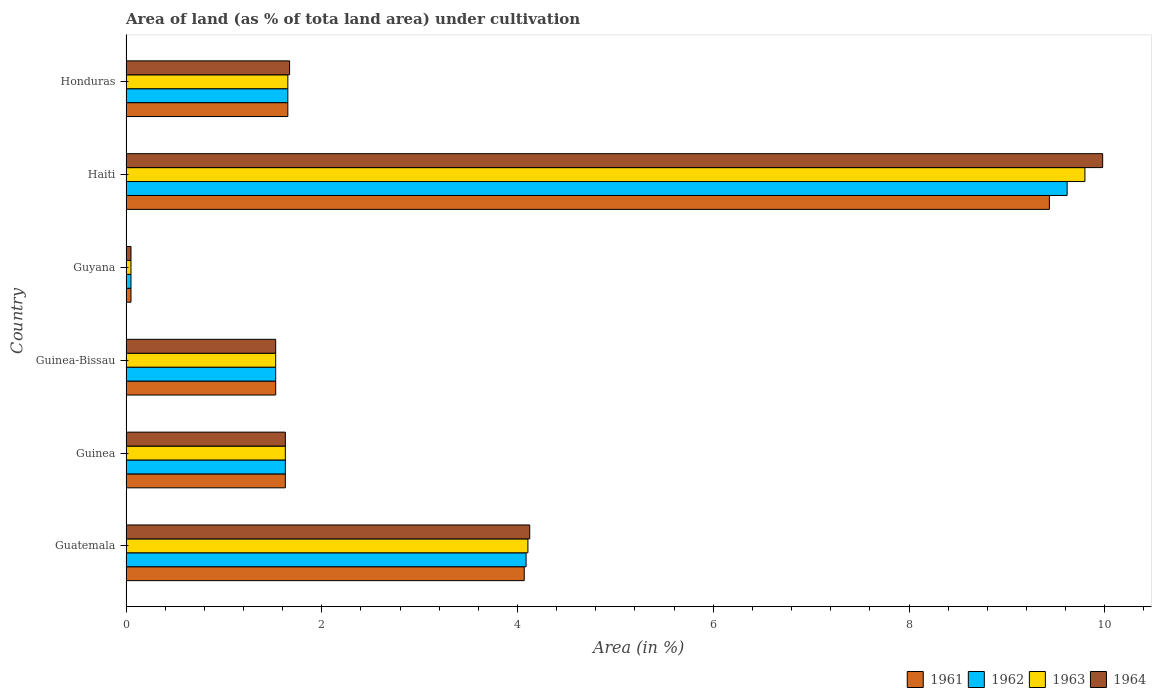Are the number of bars per tick equal to the number of legend labels?
Give a very brief answer. Yes. What is the label of the 1st group of bars from the top?
Make the answer very short. Honduras. What is the percentage of land under cultivation in 1963 in Honduras?
Provide a succinct answer. 1.65. Across all countries, what is the maximum percentage of land under cultivation in 1962?
Your response must be concise. 9.62. Across all countries, what is the minimum percentage of land under cultivation in 1964?
Give a very brief answer. 0.05. In which country was the percentage of land under cultivation in 1963 maximum?
Give a very brief answer. Haiti. In which country was the percentage of land under cultivation in 1964 minimum?
Your answer should be compact. Guyana. What is the total percentage of land under cultivation in 1964 in the graph?
Ensure brevity in your answer.  18.98. What is the difference between the percentage of land under cultivation in 1963 in Guinea and that in Honduras?
Provide a succinct answer. -0.03. What is the difference between the percentage of land under cultivation in 1962 in Guatemala and the percentage of land under cultivation in 1963 in Haiti?
Offer a very short reply. -5.71. What is the average percentage of land under cultivation in 1962 per country?
Give a very brief answer. 3.09. What is the difference between the percentage of land under cultivation in 1961 and percentage of land under cultivation in 1962 in Guatemala?
Your answer should be compact. -0.02. In how many countries, is the percentage of land under cultivation in 1962 greater than 0.8 %?
Ensure brevity in your answer.  5. What is the ratio of the percentage of land under cultivation in 1962 in Guatemala to that in Honduras?
Provide a short and direct response. 2.47. Is the percentage of land under cultivation in 1962 in Guinea less than that in Honduras?
Provide a succinct answer. Yes. Is the difference between the percentage of land under cultivation in 1961 in Guinea and Guyana greater than the difference between the percentage of land under cultivation in 1962 in Guinea and Guyana?
Offer a terse response. No. What is the difference between the highest and the second highest percentage of land under cultivation in 1961?
Your answer should be very brief. 5.37. What is the difference between the highest and the lowest percentage of land under cultivation in 1962?
Your response must be concise. 9.56. Is the sum of the percentage of land under cultivation in 1963 in Guinea-Bissau and Honduras greater than the maximum percentage of land under cultivation in 1961 across all countries?
Ensure brevity in your answer.  No. What does the 3rd bar from the bottom in Honduras represents?
Ensure brevity in your answer.  1963. How many bars are there?
Offer a terse response. 24. How many countries are there in the graph?
Ensure brevity in your answer.  6. Does the graph contain any zero values?
Provide a succinct answer. No. What is the title of the graph?
Offer a terse response. Area of land (as % of tota land area) under cultivation. What is the label or title of the X-axis?
Provide a succinct answer. Area (in %). What is the label or title of the Y-axis?
Make the answer very short. Country. What is the Area (in %) of 1961 in Guatemala?
Give a very brief answer. 4.07. What is the Area (in %) in 1962 in Guatemala?
Your response must be concise. 4.09. What is the Area (in %) in 1963 in Guatemala?
Ensure brevity in your answer.  4.11. What is the Area (in %) in 1964 in Guatemala?
Keep it short and to the point. 4.12. What is the Area (in %) of 1961 in Guinea?
Ensure brevity in your answer.  1.63. What is the Area (in %) in 1962 in Guinea?
Offer a terse response. 1.63. What is the Area (in %) of 1963 in Guinea?
Your response must be concise. 1.63. What is the Area (in %) of 1964 in Guinea?
Provide a succinct answer. 1.63. What is the Area (in %) in 1961 in Guinea-Bissau?
Offer a very short reply. 1.53. What is the Area (in %) in 1962 in Guinea-Bissau?
Your answer should be compact. 1.53. What is the Area (in %) of 1963 in Guinea-Bissau?
Provide a short and direct response. 1.53. What is the Area (in %) in 1964 in Guinea-Bissau?
Your answer should be very brief. 1.53. What is the Area (in %) in 1961 in Guyana?
Keep it short and to the point. 0.05. What is the Area (in %) in 1962 in Guyana?
Your answer should be very brief. 0.05. What is the Area (in %) of 1963 in Guyana?
Offer a very short reply. 0.05. What is the Area (in %) of 1964 in Guyana?
Your answer should be very brief. 0.05. What is the Area (in %) in 1961 in Haiti?
Give a very brief answer. 9.43. What is the Area (in %) of 1962 in Haiti?
Give a very brief answer. 9.62. What is the Area (in %) in 1963 in Haiti?
Make the answer very short. 9.8. What is the Area (in %) of 1964 in Haiti?
Offer a terse response. 9.98. What is the Area (in %) in 1961 in Honduras?
Your answer should be compact. 1.65. What is the Area (in %) in 1962 in Honduras?
Offer a very short reply. 1.65. What is the Area (in %) in 1963 in Honduras?
Ensure brevity in your answer.  1.65. What is the Area (in %) of 1964 in Honduras?
Ensure brevity in your answer.  1.67. Across all countries, what is the maximum Area (in %) of 1961?
Your response must be concise. 9.43. Across all countries, what is the maximum Area (in %) in 1962?
Make the answer very short. 9.62. Across all countries, what is the maximum Area (in %) in 1963?
Your answer should be compact. 9.8. Across all countries, what is the maximum Area (in %) of 1964?
Give a very brief answer. 9.98. Across all countries, what is the minimum Area (in %) in 1961?
Offer a very short reply. 0.05. Across all countries, what is the minimum Area (in %) of 1962?
Provide a short and direct response. 0.05. Across all countries, what is the minimum Area (in %) in 1963?
Offer a very short reply. 0.05. Across all countries, what is the minimum Area (in %) in 1964?
Give a very brief answer. 0.05. What is the total Area (in %) in 1961 in the graph?
Keep it short and to the point. 18.36. What is the total Area (in %) in 1962 in the graph?
Your response must be concise. 18.56. What is the total Area (in %) of 1963 in the graph?
Provide a short and direct response. 18.76. What is the total Area (in %) of 1964 in the graph?
Provide a short and direct response. 18.98. What is the difference between the Area (in %) of 1961 in Guatemala and that in Guinea?
Provide a short and direct response. 2.44. What is the difference between the Area (in %) in 1962 in Guatemala and that in Guinea?
Offer a terse response. 2.46. What is the difference between the Area (in %) in 1963 in Guatemala and that in Guinea?
Your answer should be very brief. 2.48. What is the difference between the Area (in %) of 1964 in Guatemala and that in Guinea?
Your response must be concise. 2.5. What is the difference between the Area (in %) in 1961 in Guatemala and that in Guinea-Bissau?
Your answer should be compact. 2.54. What is the difference between the Area (in %) of 1962 in Guatemala and that in Guinea-Bissau?
Provide a short and direct response. 2.56. What is the difference between the Area (in %) of 1963 in Guatemala and that in Guinea-Bissau?
Offer a very short reply. 2.58. What is the difference between the Area (in %) of 1964 in Guatemala and that in Guinea-Bissau?
Keep it short and to the point. 2.6. What is the difference between the Area (in %) in 1961 in Guatemala and that in Guyana?
Your answer should be very brief. 4.02. What is the difference between the Area (in %) of 1962 in Guatemala and that in Guyana?
Your answer should be very brief. 4.04. What is the difference between the Area (in %) of 1963 in Guatemala and that in Guyana?
Give a very brief answer. 4.06. What is the difference between the Area (in %) of 1964 in Guatemala and that in Guyana?
Keep it short and to the point. 4.07. What is the difference between the Area (in %) of 1961 in Guatemala and that in Haiti?
Provide a succinct answer. -5.37. What is the difference between the Area (in %) in 1962 in Guatemala and that in Haiti?
Ensure brevity in your answer.  -5.53. What is the difference between the Area (in %) in 1963 in Guatemala and that in Haiti?
Keep it short and to the point. -5.69. What is the difference between the Area (in %) in 1964 in Guatemala and that in Haiti?
Keep it short and to the point. -5.85. What is the difference between the Area (in %) of 1961 in Guatemala and that in Honduras?
Keep it short and to the point. 2.42. What is the difference between the Area (in %) of 1962 in Guatemala and that in Honduras?
Provide a succinct answer. 2.43. What is the difference between the Area (in %) in 1963 in Guatemala and that in Honduras?
Give a very brief answer. 2.45. What is the difference between the Area (in %) of 1964 in Guatemala and that in Honduras?
Offer a terse response. 2.45. What is the difference between the Area (in %) of 1961 in Guinea and that in Guinea-Bissau?
Make the answer very short. 0.1. What is the difference between the Area (in %) of 1962 in Guinea and that in Guinea-Bissau?
Offer a very short reply. 0.1. What is the difference between the Area (in %) of 1963 in Guinea and that in Guinea-Bissau?
Your answer should be compact. 0.1. What is the difference between the Area (in %) in 1964 in Guinea and that in Guinea-Bissau?
Offer a very short reply. 0.1. What is the difference between the Area (in %) of 1961 in Guinea and that in Guyana?
Give a very brief answer. 1.58. What is the difference between the Area (in %) in 1962 in Guinea and that in Guyana?
Your answer should be very brief. 1.58. What is the difference between the Area (in %) of 1963 in Guinea and that in Guyana?
Offer a very short reply. 1.58. What is the difference between the Area (in %) in 1964 in Guinea and that in Guyana?
Provide a succinct answer. 1.58. What is the difference between the Area (in %) of 1961 in Guinea and that in Haiti?
Offer a very short reply. -7.81. What is the difference between the Area (in %) in 1962 in Guinea and that in Haiti?
Provide a short and direct response. -7.99. What is the difference between the Area (in %) of 1963 in Guinea and that in Haiti?
Your answer should be very brief. -8.17. What is the difference between the Area (in %) of 1964 in Guinea and that in Haiti?
Provide a short and direct response. -8.35. What is the difference between the Area (in %) in 1961 in Guinea and that in Honduras?
Offer a very short reply. -0.03. What is the difference between the Area (in %) in 1962 in Guinea and that in Honduras?
Give a very brief answer. -0.03. What is the difference between the Area (in %) of 1963 in Guinea and that in Honduras?
Your answer should be very brief. -0.03. What is the difference between the Area (in %) in 1964 in Guinea and that in Honduras?
Your response must be concise. -0.04. What is the difference between the Area (in %) in 1961 in Guinea-Bissau and that in Guyana?
Your answer should be very brief. 1.48. What is the difference between the Area (in %) of 1962 in Guinea-Bissau and that in Guyana?
Give a very brief answer. 1.48. What is the difference between the Area (in %) in 1963 in Guinea-Bissau and that in Guyana?
Give a very brief answer. 1.48. What is the difference between the Area (in %) in 1964 in Guinea-Bissau and that in Guyana?
Make the answer very short. 1.48. What is the difference between the Area (in %) in 1961 in Guinea-Bissau and that in Haiti?
Your response must be concise. -7.9. What is the difference between the Area (in %) of 1962 in Guinea-Bissau and that in Haiti?
Your answer should be very brief. -8.09. What is the difference between the Area (in %) of 1963 in Guinea-Bissau and that in Haiti?
Ensure brevity in your answer.  -8.27. What is the difference between the Area (in %) of 1964 in Guinea-Bissau and that in Haiti?
Offer a terse response. -8.45. What is the difference between the Area (in %) in 1961 in Guinea-Bissau and that in Honduras?
Make the answer very short. -0.12. What is the difference between the Area (in %) in 1962 in Guinea-Bissau and that in Honduras?
Offer a terse response. -0.12. What is the difference between the Area (in %) of 1963 in Guinea-Bissau and that in Honduras?
Your response must be concise. -0.12. What is the difference between the Area (in %) of 1964 in Guinea-Bissau and that in Honduras?
Your answer should be very brief. -0.14. What is the difference between the Area (in %) in 1961 in Guyana and that in Haiti?
Provide a short and direct response. -9.38. What is the difference between the Area (in %) in 1962 in Guyana and that in Haiti?
Make the answer very short. -9.56. What is the difference between the Area (in %) of 1963 in Guyana and that in Haiti?
Ensure brevity in your answer.  -9.75. What is the difference between the Area (in %) of 1964 in Guyana and that in Haiti?
Offer a very short reply. -9.93. What is the difference between the Area (in %) in 1961 in Guyana and that in Honduras?
Give a very brief answer. -1.6. What is the difference between the Area (in %) in 1962 in Guyana and that in Honduras?
Offer a very short reply. -1.6. What is the difference between the Area (in %) in 1963 in Guyana and that in Honduras?
Your answer should be compact. -1.6. What is the difference between the Area (in %) in 1964 in Guyana and that in Honduras?
Offer a terse response. -1.62. What is the difference between the Area (in %) in 1961 in Haiti and that in Honduras?
Provide a short and direct response. 7.78. What is the difference between the Area (in %) of 1962 in Haiti and that in Honduras?
Offer a terse response. 7.96. What is the difference between the Area (in %) in 1963 in Haiti and that in Honduras?
Give a very brief answer. 8.14. What is the difference between the Area (in %) of 1964 in Haiti and that in Honduras?
Ensure brevity in your answer.  8.31. What is the difference between the Area (in %) in 1961 in Guatemala and the Area (in %) in 1962 in Guinea?
Offer a very short reply. 2.44. What is the difference between the Area (in %) of 1961 in Guatemala and the Area (in %) of 1963 in Guinea?
Keep it short and to the point. 2.44. What is the difference between the Area (in %) in 1961 in Guatemala and the Area (in %) in 1964 in Guinea?
Provide a succinct answer. 2.44. What is the difference between the Area (in %) in 1962 in Guatemala and the Area (in %) in 1963 in Guinea?
Make the answer very short. 2.46. What is the difference between the Area (in %) in 1962 in Guatemala and the Area (in %) in 1964 in Guinea?
Make the answer very short. 2.46. What is the difference between the Area (in %) of 1963 in Guatemala and the Area (in %) of 1964 in Guinea?
Provide a succinct answer. 2.48. What is the difference between the Area (in %) of 1961 in Guatemala and the Area (in %) of 1962 in Guinea-Bissau?
Offer a terse response. 2.54. What is the difference between the Area (in %) of 1961 in Guatemala and the Area (in %) of 1963 in Guinea-Bissau?
Offer a terse response. 2.54. What is the difference between the Area (in %) in 1961 in Guatemala and the Area (in %) in 1964 in Guinea-Bissau?
Provide a short and direct response. 2.54. What is the difference between the Area (in %) of 1962 in Guatemala and the Area (in %) of 1963 in Guinea-Bissau?
Provide a succinct answer. 2.56. What is the difference between the Area (in %) of 1962 in Guatemala and the Area (in %) of 1964 in Guinea-Bissau?
Offer a terse response. 2.56. What is the difference between the Area (in %) in 1963 in Guatemala and the Area (in %) in 1964 in Guinea-Bissau?
Provide a succinct answer. 2.58. What is the difference between the Area (in %) of 1961 in Guatemala and the Area (in %) of 1962 in Guyana?
Provide a short and direct response. 4.02. What is the difference between the Area (in %) in 1961 in Guatemala and the Area (in %) in 1963 in Guyana?
Your answer should be very brief. 4.02. What is the difference between the Area (in %) of 1961 in Guatemala and the Area (in %) of 1964 in Guyana?
Provide a short and direct response. 4.02. What is the difference between the Area (in %) of 1962 in Guatemala and the Area (in %) of 1963 in Guyana?
Offer a terse response. 4.04. What is the difference between the Area (in %) of 1962 in Guatemala and the Area (in %) of 1964 in Guyana?
Your answer should be very brief. 4.04. What is the difference between the Area (in %) in 1963 in Guatemala and the Area (in %) in 1964 in Guyana?
Ensure brevity in your answer.  4.06. What is the difference between the Area (in %) of 1961 in Guatemala and the Area (in %) of 1962 in Haiti?
Provide a short and direct response. -5.55. What is the difference between the Area (in %) of 1961 in Guatemala and the Area (in %) of 1963 in Haiti?
Provide a short and direct response. -5.73. What is the difference between the Area (in %) of 1961 in Guatemala and the Area (in %) of 1964 in Haiti?
Provide a succinct answer. -5.91. What is the difference between the Area (in %) of 1962 in Guatemala and the Area (in %) of 1963 in Haiti?
Your answer should be compact. -5.71. What is the difference between the Area (in %) of 1962 in Guatemala and the Area (in %) of 1964 in Haiti?
Make the answer very short. -5.89. What is the difference between the Area (in %) in 1963 in Guatemala and the Area (in %) in 1964 in Haiti?
Keep it short and to the point. -5.87. What is the difference between the Area (in %) of 1961 in Guatemala and the Area (in %) of 1962 in Honduras?
Provide a short and direct response. 2.42. What is the difference between the Area (in %) of 1961 in Guatemala and the Area (in %) of 1963 in Honduras?
Make the answer very short. 2.42. What is the difference between the Area (in %) of 1961 in Guatemala and the Area (in %) of 1964 in Honduras?
Keep it short and to the point. 2.4. What is the difference between the Area (in %) in 1962 in Guatemala and the Area (in %) in 1963 in Honduras?
Keep it short and to the point. 2.43. What is the difference between the Area (in %) in 1962 in Guatemala and the Area (in %) in 1964 in Honduras?
Your response must be concise. 2.42. What is the difference between the Area (in %) of 1963 in Guatemala and the Area (in %) of 1964 in Honduras?
Keep it short and to the point. 2.43. What is the difference between the Area (in %) in 1961 in Guinea and the Area (in %) in 1962 in Guinea-Bissau?
Your answer should be very brief. 0.1. What is the difference between the Area (in %) in 1961 in Guinea and the Area (in %) in 1963 in Guinea-Bissau?
Give a very brief answer. 0.1. What is the difference between the Area (in %) of 1961 in Guinea and the Area (in %) of 1964 in Guinea-Bissau?
Ensure brevity in your answer.  0.1. What is the difference between the Area (in %) in 1962 in Guinea and the Area (in %) in 1963 in Guinea-Bissau?
Make the answer very short. 0.1. What is the difference between the Area (in %) of 1962 in Guinea and the Area (in %) of 1964 in Guinea-Bissau?
Give a very brief answer. 0.1. What is the difference between the Area (in %) in 1963 in Guinea and the Area (in %) in 1964 in Guinea-Bissau?
Ensure brevity in your answer.  0.1. What is the difference between the Area (in %) of 1961 in Guinea and the Area (in %) of 1962 in Guyana?
Your answer should be compact. 1.58. What is the difference between the Area (in %) of 1961 in Guinea and the Area (in %) of 1963 in Guyana?
Give a very brief answer. 1.58. What is the difference between the Area (in %) of 1961 in Guinea and the Area (in %) of 1964 in Guyana?
Your answer should be compact. 1.58. What is the difference between the Area (in %) in 1962 in Guinea and the Area (in %) in 1963 in Guyana?
Your response must be concise. 1.58. What is the difference between the Area (in %) in 1962 in Guinea and the Area (in %) in 1964 in Guyana?
Offer a terse response. 1.58. What is the difference between the Area (in %) in 1963 in Guinea and the Area (in %) in 1964 in Guyana?
Offer a terse response. 1.58. What is the difference between the Area (in %) in 1961 in Guinea and the Area (in %) in 1962 in Haiti?
Your answer should be compact. -7.99. What is the difference between the Area (in %) in 1961 in Guinea and the Area (in %) in 1963 in Haiti?
Keep it short and to the point. -8.17. What is the difference between the Area (in %) of 1961 in Guinea and the Area (in %) of 1964 in Haiti?
Offer a terse response. -8.35. What is the difference between the Area (in %) of 1962 in Guinea and the Area (in %) of 1963 in Haiti?
Offer a very short reply. -8.17. What is the difference between the Area (in %) in 1962 in Guinea and the Area (in %) in 1964 in Haiti?
Give a very brief answer. -8.35. What is the difference between the Area (in %) in 1963 in Guinea and the Area (in %) in 1964 in Haiti?
Keep it short and to the point. -8.35. What is the difference between the Area (in %) of 1961 in Guinea and the Area (in %) of 1962 in Honduras?
Offer a terse response. -0.03. What is the difference between the Area (in %) of 1961 in Guinea and the Area (in %) of 1963 in Honduras?
Keep it short and to the point. -0.03. What is the difference between the Area (in %) in 1961 in Guinea and the Area (in %) in 1964 in Honduras?
Your answer should be very brief. -0.04. What is the difference between the Area (in %) of 1962 in Guinea and the Area (in %) of 1963 in Honduras?
Your answer should be very brief. -0.03. What is the difference between the Area (in %) of 1962 in Guinea and the Area (in %) of 1964 in Honduras?
Keep it short and to the point. -0.04. What is the difference between the Area (in %) in 1963 in Guinea and the Area (in %) in 1964 in Honduras?
Your answer should be compact. -0.04. What is the difference between the Area (in %) in 1961 in Guinea-Bissau and the Area (in %) in 1962 in Guyana?
Provide a succinct answer. 1.48. What is the difference between the Area (in %) in 1961 in Guinea-Bissau and the Area (in %) in 1963 in Guyana?
Provide a succinct answer. 1.48. What is the difference between the Area (in %) of 1961 in Guinea-Bissau and the Area (in %) of 1964 in Guyana?
Make the answer very short. 1.48. What is the difference between the Area (in %) of 1962 in Guinea-Bissau and the Area (in %) of 1963 in Guyana?
Ensure brevity in your answer.  1.48. What is the difference between the Area (in %) in 1962 in Guinea-Bissau and the Area (in %) in 1964 in Guyana?
Give a very brief answer. 1.48. What is the difference between the Area (in %) in 1963 in Guinea-Bissau and the Area (in %) in 1964 in Guyana?
Your response must be concise. 1.48. What is the difference between the Area (in %) of 1961 in Guinea-Bissau and the Area (in %) of 1962 in Haiti?
Make the answer very short. -8.09. What is the difference between the Area (in %) in 1961 in Guinea-Bissau and the Area (in %) in 1963 in Haiti?
Offer a very short reply. -8.27. What is the difference between the Area (in %) in 1961 in Guinea-Bissau and the Area (in %) in 1964 in Haiti?
Provide a succinct answer. -8.45. What is the difference between the Area (in %) of 1962 in Guinea-Bissau and the Area (in %) of 1963 in Haiti?
Offer a terse response. -8.27. What is the difference between the Area (in %) of 1962 in Guinea-Bissau and the Area (in %) of 1964 in Haiti?
Offer a very short reply. -8.45. What is the difference between the Area (in %) of 1963 in Guinea-Bissau and the Area (in %) of 1964 in Haiti?
Ensure brevity in your answer.  -8.45. What is the difference between the Area (in %) of 1961 in Guinea-Bissau and the Area (in %) of 1962 in Honduras?
Give a very brief answer. -0.12. What is the difference between the Area (in %) of 1961 in Guinea-Bissau and the Area (in %) of 1963 in Honduras?
Make the answer very short. -0.12. What is the difference between the Area (in %) of 1961 in Guinea-Bissau and the Area (in %) of 1964 in Honduras?
Ensure brevity in your answer.  -0.14. What is the difference between the Area (in %) of 1962 in Guinea-Bissau and the Area (in %) of 1963 in Honduras?
Provide a short and direct response. -0.12. What is the difference between the Area (in %) in 1962 in Guinea-Bissau and the Area (in %) in 1964 in Honduras?
Provide a succinct answer. -0.14. What is the difference between the Area (in %) of 1963 in Guinea-Bissau and the Area (in %) of 1964 in Honduras?
Keep it short and to the point. -0.14. What is the difference between the Area (in %) of 1961 in Guyana and the Area (in %) of 1962 in Haiti?
Your response must be concise. -9.56. What is the difference between the Area (in %) of 1961 in Guyana and the Area (in %) of 1963 in Haiti?
Your answer should be very brief. -9.75. What is the difference between the Area (in %) of 1961 in Guyana and the Area (in %) of 1964 in Haiti?
Keep it short and to the point. -9.93. What is the difference between the Area (in %) in 1962 in Guyana and the Area (in %) in 1963 in Haiti?
Give a very brief answer. -9.75. What is the difference between the Area (in %) in 1962 in Guyana and the Area (in %) in 1964 in Haiti?
Offer a terse response. -9.93. What is the difference between the Area (in %) of 1963 in Guyana and the Area (in %) of 1964 in Haiti?
Offer a very short reply. -9.93. What is the difference between the Area (in %) of 1961 in Guyana and the Area (in %) of 1962 in Honduras?
Provide a succinct answer. -1.6. What is the difference between the Area (in %) in 1961 in Guyana and the Area (in %) in 1963 in Honduras?
Provide a succinct answer. -1.6. What is the difference between the Area (in %) of 1961 in Guyana and the Area (in %) of 1964 in Honduras?
Offer a terse response. -1.62. What is the difference between the Area (in %) in 1962 in Guyana and the Area (in %) in 1963 in Honduras?
Give a very brief answer. -1.6. What is the difference between the Area (in %) of 1962 in Guyana and the Area (in %) of 1964 in Honduras?
Ensure brevity in your answer.  -1.62. What is the difference between the Area (in %) of 1963 in Guyana and the Area (in %) of 1964 in Honduras?
Provide a succinct answer. -1.62. What is the difference between the Area (in %) in 1961 in Haiti and the Area (in %) in 1962 in Honduras?
Make the answer very short. 7.78. What is the difference between the Area (in %) of 1961 in Haiti and the Area (in %) of 1963 in Honduras?
Give a very brief answer. 7.78. What is the difference between the Area (in %) in 1961 in Haiti and the Area (in %) in 1964 in Honduras?
Provide a short and direct response. 7.76. What is the difference between the Area (in %) in 1962 in Haiti and the Area (in %) in 1963 in Honduras?
Ensure brevity in your answer.  7.96. What is the difference between the Area (in %) of 1962 in Haiti and the Area (in %) of 1964 in Honduras?
Provide a short and direct response. 7.94. What is the difference between the Area (in %) of 1963 in Haiti and the Area (in %) of 1964 in Honduras?
Keep it short and to the point. 8.13. What is the average Area (in %) of 1961 per country?
Provide a succinct answer. 3.06. What is the average Area (in %) of 1962 per country?
Offer a terse response. 3.09. What is the average Area (in %) of 1963 per country?
Your answer should be very brief. 3.13. What is the average Area (in %) in 1964 per country?
Provide a succinct answer. 3.16. What is the difference between the Area (in %) of 1961 and Area (in %) of 1962 in Guatemala?
Your answer should be compact. -0.02. What is the difference between the Area (in %) of 1961 and Area (in %) of 1963 in Guatemala?
Give a very brief answer. -0.04. What is the difference between the Area (in %) of 1961 and Area (in %) of 1964 in Guatemala?
Provide a succinct answer. -0.06. What is the difference between the Area (in %) in 1962 and Area (in %) in 1963 in Guatemala?
Provide a short and direct response. -0.02. What is the difference between the Area (in %) in 1962 and Area (in %) in 1964 in Guatemala?
Provide a succinct answer. -0.04. What is the difference between the Area (in %) in 1963 and Area (in %) in 1964 in Guatemala?
Your answer should be compact. -0.02. What is the difference between the Area (in %) in 1961 and Area (in %) in 1963 in Guinea?
Your answer should be very brief. 0. What is the difference between the Area (in %) in 1961 and Area (in %) in 1964 in Guinea?
Give a very brief answer. 0. What is the difference between the Area (in %) in 1962 and Area (in %) in 1964 in Guinea?
Offer a very short reply. 0. What is the difference between the Area (in %) of 1963 and Area (in %) of 1964 in Guinea?
Make the answer very short. 0. What is the difference between the Area (in %) of 1961 and Area (in %) of 1963 in Guinea-Bissau?
Keep it short and to the point. 0. What is the difference between the Area (in %) of 1962 and Area (in %) of 1963 in Guinea-Bissau?
Keep it short and to the point. 0. What is the difference between the Area (in %) of 1962 and Area (in %) of 1964 in Guinea-Bissau?
Your answer should be very brief. 0. What is the difference between the Area (in %) in 1963 and Area (in %) in 1964 in Guinea-Bissau?
Offer a terse response. 0. What is the difference between the Area (in %) of 1961 and Area (in %) of 1962 in Guyana?
Ensure brevity in your answer.  0. What is the difference between the Area (in %) in 1962 and Area (in %) in 1963 in Guyana?
Ensure brevity in your answer.  0. What is the difference between the Area (in %) of 1962 and Area (in %) of 1964 in Guyana?
Offer a terse response. 0. What is the difference between the Area (in %) in 1963 and Area (in %) in 1964 in Guyana?
Provide a succinct answer. 0. What is the difference between the Area (in %) of 1961 and Area (in %) of 1962 in Haiti?
Offer a terse response. -0.18. What is the difference between the Area (in %) in 1961 and Area (in %) in 1963 in Haiti?
Ensure brevity in your answer.  -0.36. What is the difference between the Area (in %) in 1961 and Area (in %) in 1964 in Haiti?
Provide a succinct answer. -0.54. What is the difference between the Area (in %) in 1962 and Area (in %) in 1963 in Haiti?
Your answer should be very brief. -0.18. What is the difference between the Area (in %) of 1962 and Area (in %) of 1964 in Haiti?
Offer a terse response. -0.36. What is the difference between the Area (in %) of 1963 and Area (in %) of 1964 in Haiti?
Your response must be concise. -0.18. What is the difference between the Area (in %) of 1961 and Area (in %) of 1962 in Honduras?
Ensure brevity in your answer.  0. What is the difference between the Area (in %) in 1961 and Area (in %) in 1964 in Honduras?
Provide a short and direct response. -0.02. What is the difference between the Area (in %) of 1962 and Area (in %) of 1964 in Honduras?
Offer a terse response. -0.02. What is the difference between the Area (in %) in 1963 and Area (in %) in 1964 in Honduras?
Make the answer very short. -0.02. What is the ratio of the Area (in %) in 1961 in Guatemala to that in Guinea?
Ensure brevity in your answer.  2.5. What is the ratio of the Area (in %) of 1962 in Guatemala to that in Guinea?
Your answer should be compact. 2.51. What is the ratio of the Area (in %) in 1963 in Guatemala to that in Guinea?
Give a very brief answer. 2.52. What is the ratio of the Area (in %) of 1964 in Guatemala to that in Guinea?
Offer a very short reply. 2.53. What is the ratio of the Area (in %) in 1961 in Guatemala to that in Guinea-Bissau?
Your answer should be very brief. 2.66. What is the ratio of the Area (in %) in 1962 in Guatemala to that in Guinea-Bissau?
Offer a terse response. 2.67. What is the ratio of the Area (in %) of 1963 in Guatemala to that in Guinea-Bissau?
Provide a short and direct response. 2.69. What is the ratio of the Area (in %) in 1964 in Guatemala to that in Guinea-Bissau?
Provide a short and direct response. 2.7. What is the ratio of the Area (in %) in 1961 in Guatemala to that in Guyana?
Your answer should be compact. 80.04. What is the ratio of the Area (in %) in 1962 in Guatemala to that in Guyana?
Your response must be concise. 80.4. What is the ratio of the Area (in %) of 1963 in Guatemala to that in Guyana?
Keep it short and to the point. 80.77. What is the ratio of the Area (in %) in 1964 in Guatemala to that in Guyana?
Your response must be concise. 81.14. What is the ratio of the Area (in %) in 1961 in Guatemala to that in Haiti?
Your response must be concise. 0.43. What is the ratio of the Area (in %) in 1962 in Guatemala to that in Haiti?
Offer a very short reply. 0.43. What is the ratio of the Area (in %) of 1963 in Guatemala to that in Haiti?
Make the answer very short. 0.42. What is the ratio of the Area (in %) of 1964 in Guatemala to that in Haiti?
Your response must be concise. 0.41. What is the ratio of the Area (in %) in 1961 in Guatemala to that in Honduras?
Keep it short and to the point. 2.46. What is the ratio of the Area (in %) of 1962 in Guatemala to that in Honduras?
Your response must be concise. 2.47. What is the ratio of the Area (in %) of 1963 in Guatemala to that in Honduras?
Keep it short and to the point. 2.48. What is the ratio of the Area (in %) in 1964 in Guatemala to that in Honduras?
Give a very brief answer. 2.47. What is the ratio of the Area (in %) in 1961 in Guinea to that in Guinea-Bissau?
Give a very brief answer. 1.06. What is the ratio of the Area (in %) in 1962 in Guinea to that in Guinea-Bissau?
Keep it short and to the point. 1.06. What is the ratio of the Area (in %) of 1963 in Guinea to that in Guinea-Bissau?
Make the answer very short. 1.06. What is the ratio of the Area (in %) of 1964 in Guinea to that in Guinea-Bissau?
Your answer should be compact. 1.06. What is the ratio of the Area (in %) of 1961 in Guinea to that in Guyana?
Give a very brief answer. 32.02. What is the ratio of the Area (in %) of 1962 in Guinea to that in Guyana?
Your response must be concise. 32.02. What is the ratio of the Area (in %) in 1963 in Guinea to that in Guyana?
Your response must be concise. 32.02. What is the ratio of the Area (in %) in 1964 in Guinea to that in Guyana?
Your answer should be compact. 32.02. What is the ratio of the Area (in %) of 1961 in Guinea to that in Haiti?
Provide a short and direct response. 0.17. What is the ratio of the Area (in %) in 1962 in Guinea to that in Haiti?
Keep it short and to the point. 0.17. What is the ratio of the Area (in %) of 1963 in Guinea to that in Haiti?
Provide a succinct answer. 0.17. What is the ratio of the Area (in %) in 1964 in Guinea to that in Haiti?
Your response must be concise. 0.16. What is the ratio of the Area (in %) of 1961 in Guinea to that in Honduras?
Your answer should be very brief. 0.98. What is the ratio of the Area (in %) of 1962 in Guinea to that in Honduras?
Your answer should be very brief. 0.98. What is the ratio of the Area (in %) of 1963 in Guinea to that in Honduras?
Give a very brief answer. 0.98. What is the ratio of the Area (in %) of 1961 in Guinea-Bissau to that in Guyana?
Give a very brief answer. 30.08. What is the ratio of the Area (in %) of 1962 in Guinea-Bissau to that in Guyana?
Your answer should be compact. 30.08. What is the ratio of the Area (in %) in 1963 in Guinea-Bissau to that in Guyana?
Your response must be concise. 30.08. What is the ratio of the Area (in %) of 1964 in Guinea-Bissau to that in Guyana?
Your answer should be very brief. 30.08. What is the ratio of the Area (in %) of 1961 in Guinea-Bissau to that in Haiti?
Give a very brief answer. 0.16. What is the ratio of the Area (in %) of 1962 in Guinea-Bissau to that in Haiti?
Provide a short and direct response. 0.16. What is the ratio of the Area (in %) in 1963 in Guinea-Bissau to that in Haiti?
Offer a very short reply. 0.16. What is the ratio of the Area (in %) of 1964 in Guinea-Bissau to that in Haiti?
Give a very brief answer. 0.15. What is the ratio of the Area (in %) of 1961 in Guinea-Bissau to that in Honduras?
Your answer should be very brief. 0.92. What is the ratio of the Area (in %) in 1962 in Guinea-Bissau to that in Honduras?
Offer a terse response. 0.92. What is the ratio of the Area (in %) of 1963 in Guinea-Bissau to that in Honduras?
Offer a terse response. 0.92. What is the ratio of the Area (in %) in 1964 in Guinea-Bissau to that in Honduras?
Offer a terse response. 0.92. What is the ratio of the Area (in %) of 1961 in Guyana to that in Haiti?
Keep it short and to the point. 0.01. What is the ratio of the Area (in %) in 1962 in Guyana to that in Haiti?
Keep it short and to the point. 0.01. What is the ratio of the Area (in %) of 1963 in Guyana to that in Haiti?
Your answer should be compact. 0.01. What is the ratio of the Area (in %) of 1964 in Guyana to that in Haiti?
Ensure brevity in your answer.  0.01. What is the ratio of the Area (in %) in 1961 in Guyana to that in Honduras?
Make the answer very short. 0.03. What is the ratio of the Area (in %) in 1962 in Guyana to that in Honduras?
Your answer should be very brief. 0.03. What is the ratio of the Area (in %) in 1963 in Guyana to that in Honduras?
Provide a succinct answer. 0.03. What is the ratio of the Area (in %) of 1964 in Guyana to that in Honduras?
Offer a terse response. 0.03. What is the ratio of the Area (in %) in 1961 in Haiti to that in Honduras?
Your answer should be compact. 5.71. What is the ratio of the Area (in %) of 1962 in Haiti to that in Honduras?
Offer a terse response. 5.82. What is the ratio of the Area (in %) of 1963 in Haiti to that in Honduras?
Make the answer very short. 5.93. What is the ratio of the Area (in %) in 1964 in Haiti to that in Honduras?
Your answer should be very brief. 5.97. What is the difference between the highest and the second highest Area (in %) in 1961?
Your response must be concise. 5.37. What is the difference between the highest and the second highest Area (in %) in 1962?
Your answer should be compact. 5.53. What is the difference between the highest and the second highest Area (in %) of 1963?
Give a very brief answer. 5.69. What is the difference between the highest and the second highest Area (in %) of 1964?
Give a very brief answer. 5.85. What is the difference between the highest and the lowest Area (in %) of 1961?
Your answer should be compact. 9.38. What is the difference between the highest and the lowest Area (in %) in 1962?
Make the answer very short. 9.56. What is the difference between the highest and the lowest Area (in %) in 1963?
Ensure brevity in your answer.  9.75. What is the difference between the highest and the lowest Area (in %) in 1964?
Give a very brief answer. 9.93. 